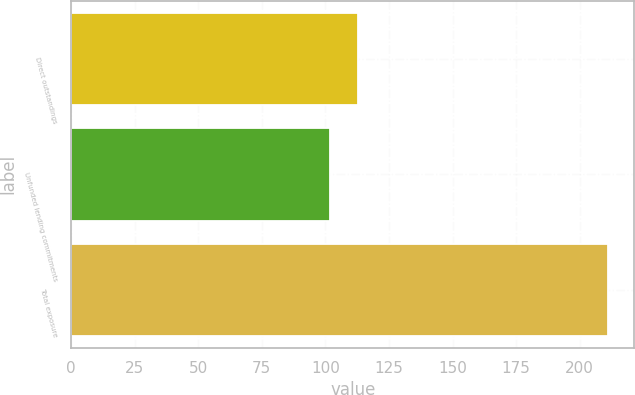<chart> <loc_0><loc_0><loc_500><loc_500><bar_chart><fcel>Direct outstandings<fcel>Unfunded lending commitments<fcel>Total exposure<nl><fcel>112.9<fcel>102<fcel>211<nl></chart> 